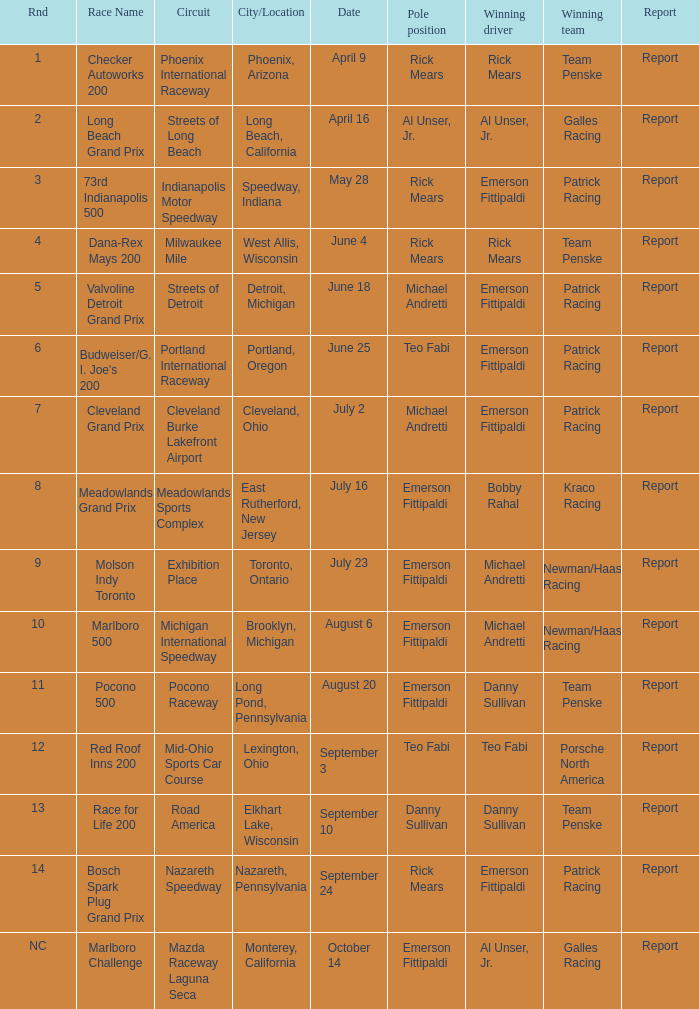How many reports were the for the cleveland burke lakefront airport circut? 1.0. 